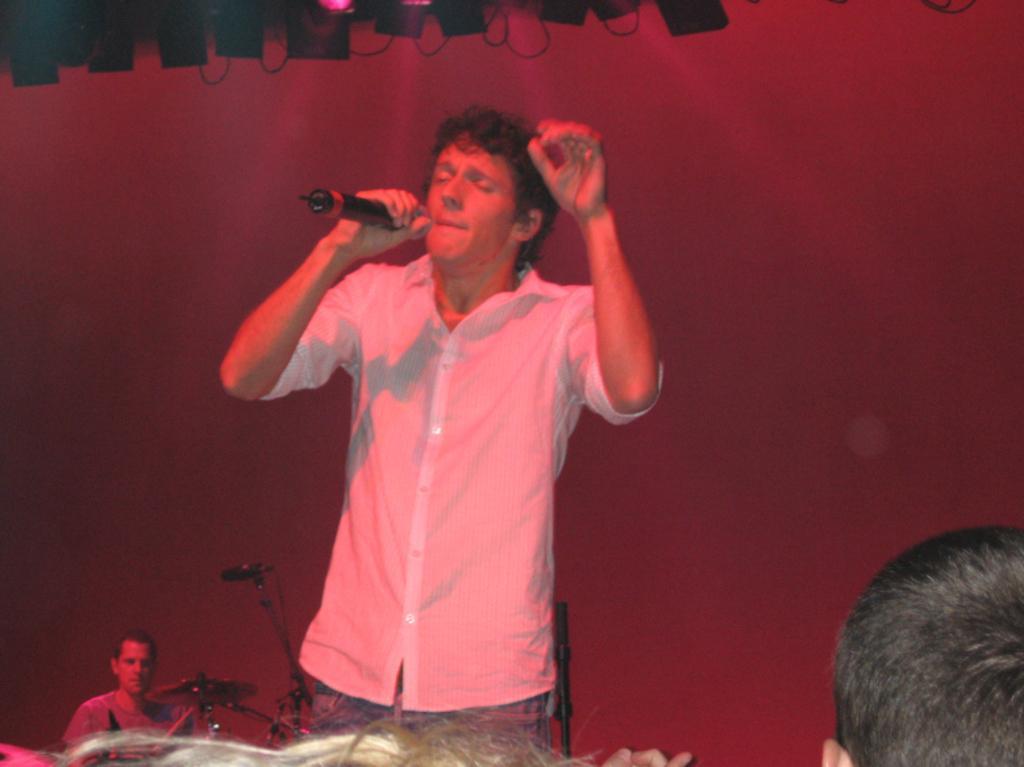Describe this image in one or two sentences. In this image there is a person wearing white color dress holding microphone in his hands and at the background of the image there is a person who is beating drums. 